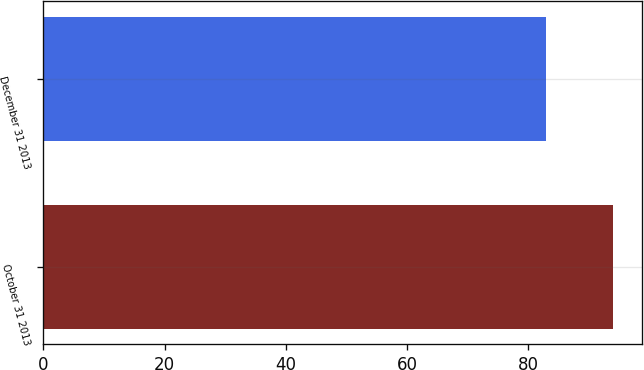Convert chart. <chart><loc_0><loc_0><loc_500><loc_500><bar_chart><fcel>October 31 2013<fcel>December 31 2013<nl><fcel>94<fcel>83<nl></chart> 